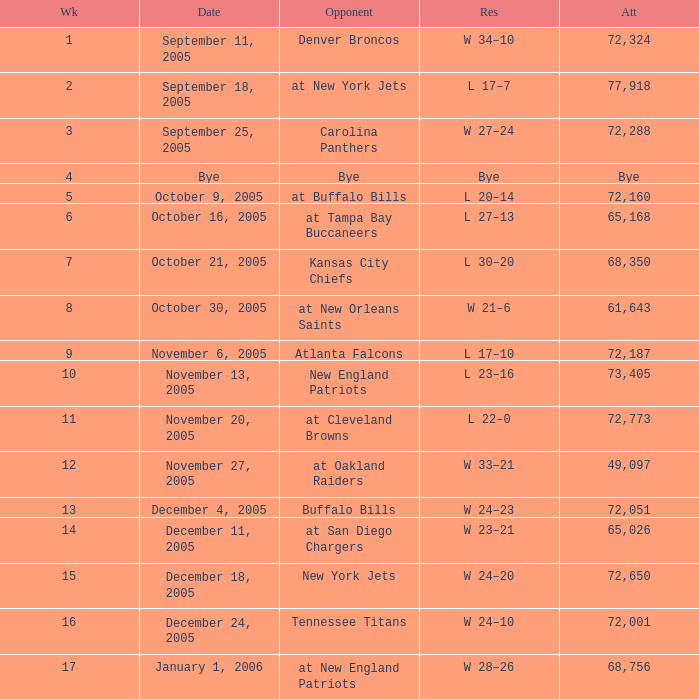What is the Week with a Date of Bye? 1.0. 